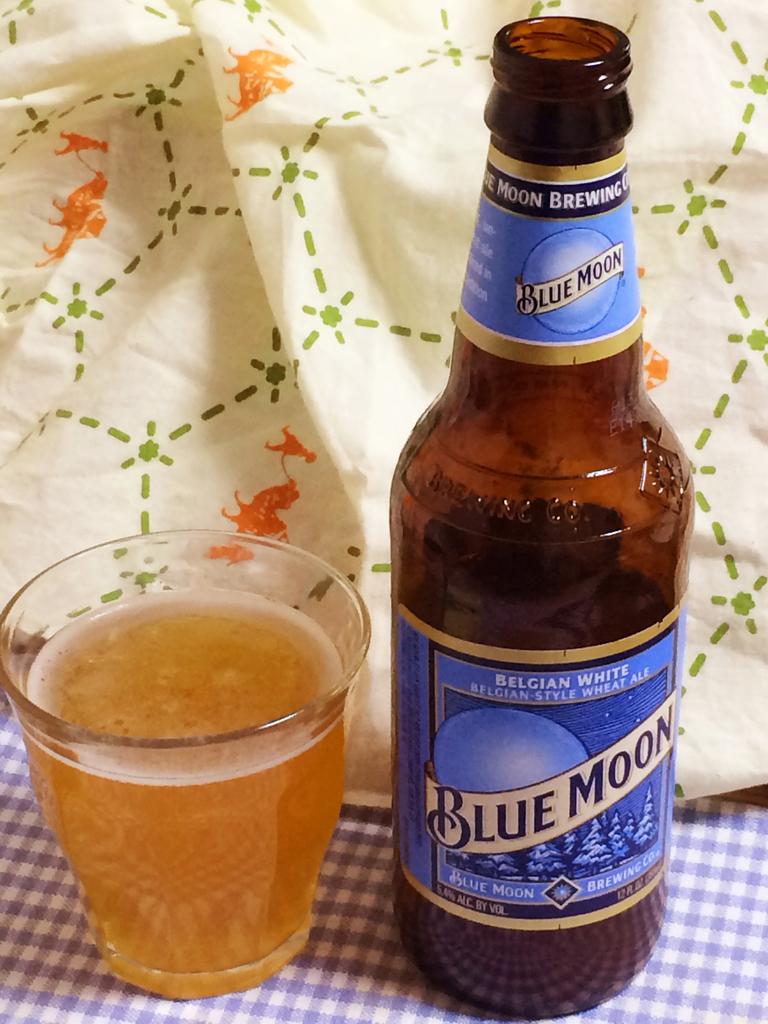What kind of beer is this?
Your answer should be compact. Blue moon. 